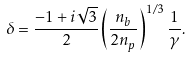<formula> <loc_0><loc_0><loc_500><loc_500>\delta = \frac { - 1 + i \sqrt { 3 } } { 2 } \left ( \frac { n _ { b } } { 2 n _ { p } } \right ) ^ { 1 / 3 } \frac { 1 } { \gamma } .</formula> 